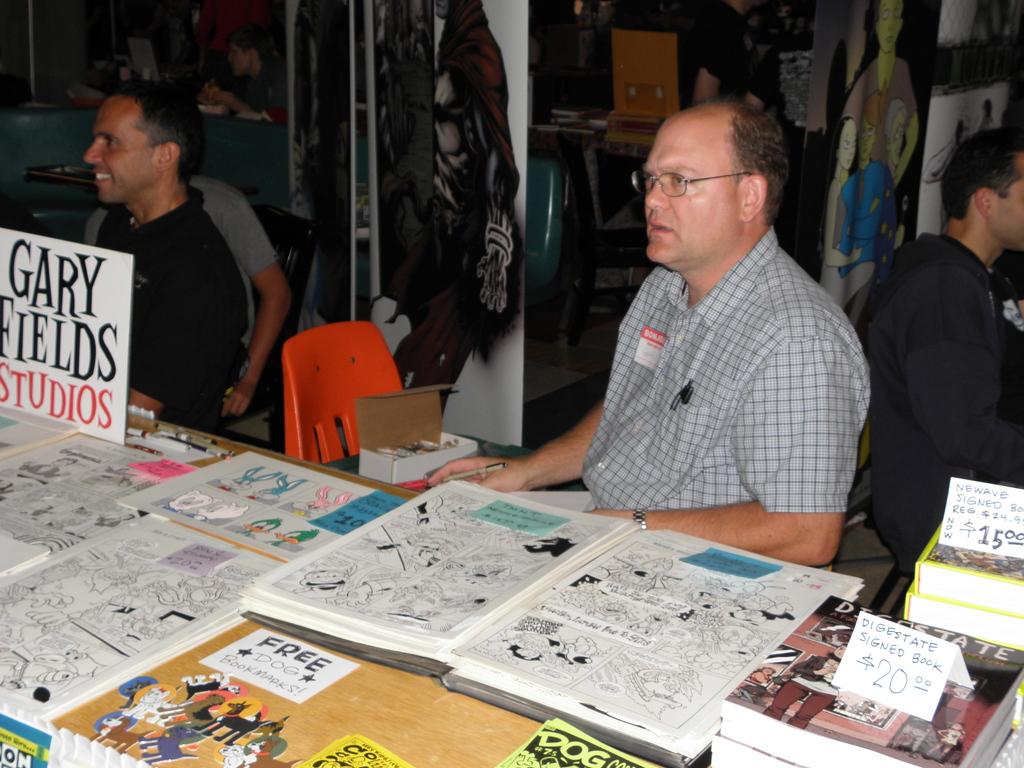What is being given away free?
Provide a short and direct response. Dog bookmarks. What studios are these comics made in/?
Offer a terse response. Gary fields. 